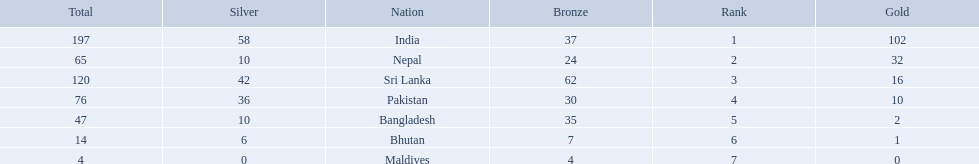Which nations played at the 1999 south asian games? India, Nepal, Sri Lanka, Pakistan, Bangladesh, Bhutan, Maldives. Which country is listed second in the table? Nepal. What were the total amount won of medals by nations in the 1999 south asian games? 197, 65, 120, 76, 47, 14, 4. Which amount was the lowest? 4. Which nation had this amount? Maldives. 